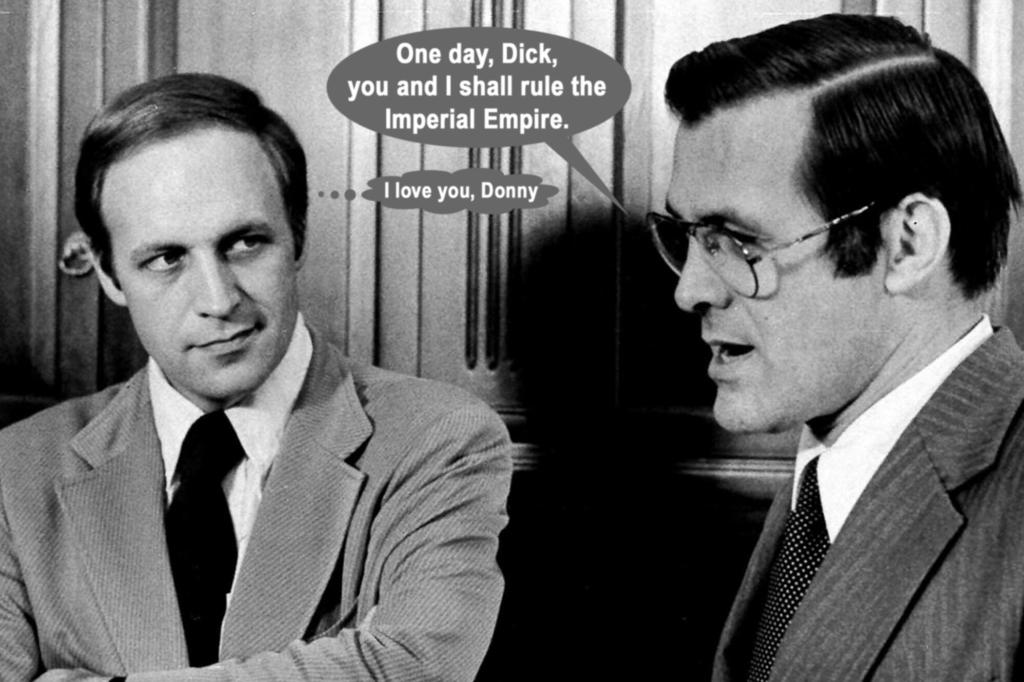What is the main object in the image? There is a poster in the image. Can you describe the people in the image? Two people are present in the image, and they are wearing suits. What is written or depicted in the center of the image? There is text written in the center of the image. What type of material is the background made of? The background of the image is wooden. What color scheme is used in the image? The image is black and white. What type of jail is depicted in the image? There is no jail depicted in the image; it features a poster with text and two people wearing suits. What territory is being claimed in the image? There is no territory being claimed in the image; it features a poster with text and two people wearing suits. 